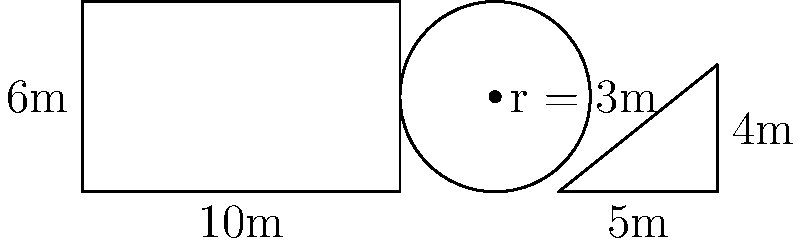As the casino floor manager, you need to calculate the total area of the new floor plan. The plan consists of a rectangular main area, a circular VIP lounge, and a triangular high-stakes section. Given the dimensions in the diagram, what is the total area of the casino floor in square meters? Let's calculate the area of each section:

1. Rectangular main area:
   $A_{rectangle} = length \times width = 10m \times 6m = 60m^2$

2. Circular VIP lounge:
   $A_{circle} = \pi r^2 = \pi \times (3m)^2 = 9\pi m^2$

3. Triangular high-stakes section:
   $A_{triangle} = \frac{1}{2} \times base \times height = \frac{1}{2} \times 5m \times 4m = 10m^2$

Now, we sum up all the areas:

$A_{total} = A_{rectangle} + A_{circle} + A_{triangle}$
$A_{total} = 60m^2 + 9\pi m^2 + 10m^2$
$A_{total} = 70m^2 + 9\pi m^2$

The exact value is $70 + 9\pi \approx 98.27m^2$, but we'll keep it in its exact form for precision.
Answer: $70 + 9\pi$ square meters 